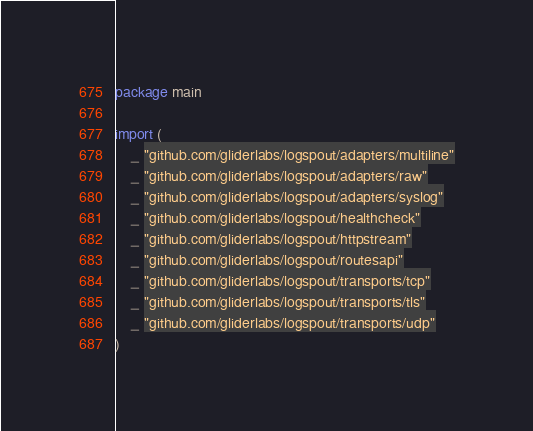<code> <loc_0><loc_0><loc_500><loc_500><_Go_>package main

import (
	_ "github.com/gliderlabs/logspout/adapters/multiline"
	_ "github.com/gliderlabs/logspout/adapters/raw"
	_ "github.com/gliderlabs/logspout/adapters/syslog"
	_ "github.com/gliderlabs/logspout/healthcheck"
	_ "github.com/gliderlabs/logspout/httpstream"
	_ "github.com/gliderlabs/logspout/routesapi"
	_ "github.com/gliderlabs/logspout/transports/tcp"
	_ "github.com/gliderlabs/logspout/transports/tls"
	_ "github.com/gliderlabs/logspout/transports/udp"
)
</code> 